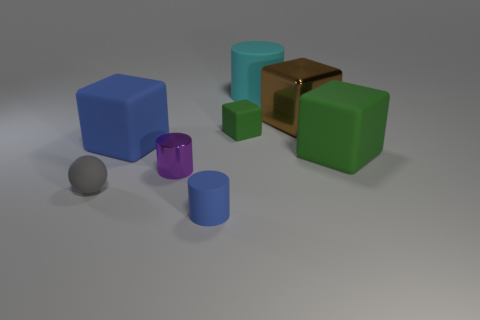Subtract all rubber blocks. How many blocks are left? 1 Subtract all red balls. How many green cubes are left? 2 Subtract all blue cubes. How many cubes are left? 3 Subtract 1 cubes. How many cubes are left? 3 Subtract all cyan cubes. Subtract all gray cylinders. How many cubes are left? 4 Add 2 tiny gray rubber spheres. How many objects exist? 10 Subtract all spheres. How many objects are left? 7 Subtract all tiny green metallic cylinders. Subtract all small blue matte things. How many objects are left? 7 Add 5 big matte objects. How many big matte objects are left? 8 Add 3 large brown metal things. How many large brown metal things exist? 4 